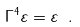Convert formula to latex. <formula><loc_0><loc_0><loc_500><loc_500>\Gamma ^ { 4 } \varepsilon = \varepsilon \ .</formula> 